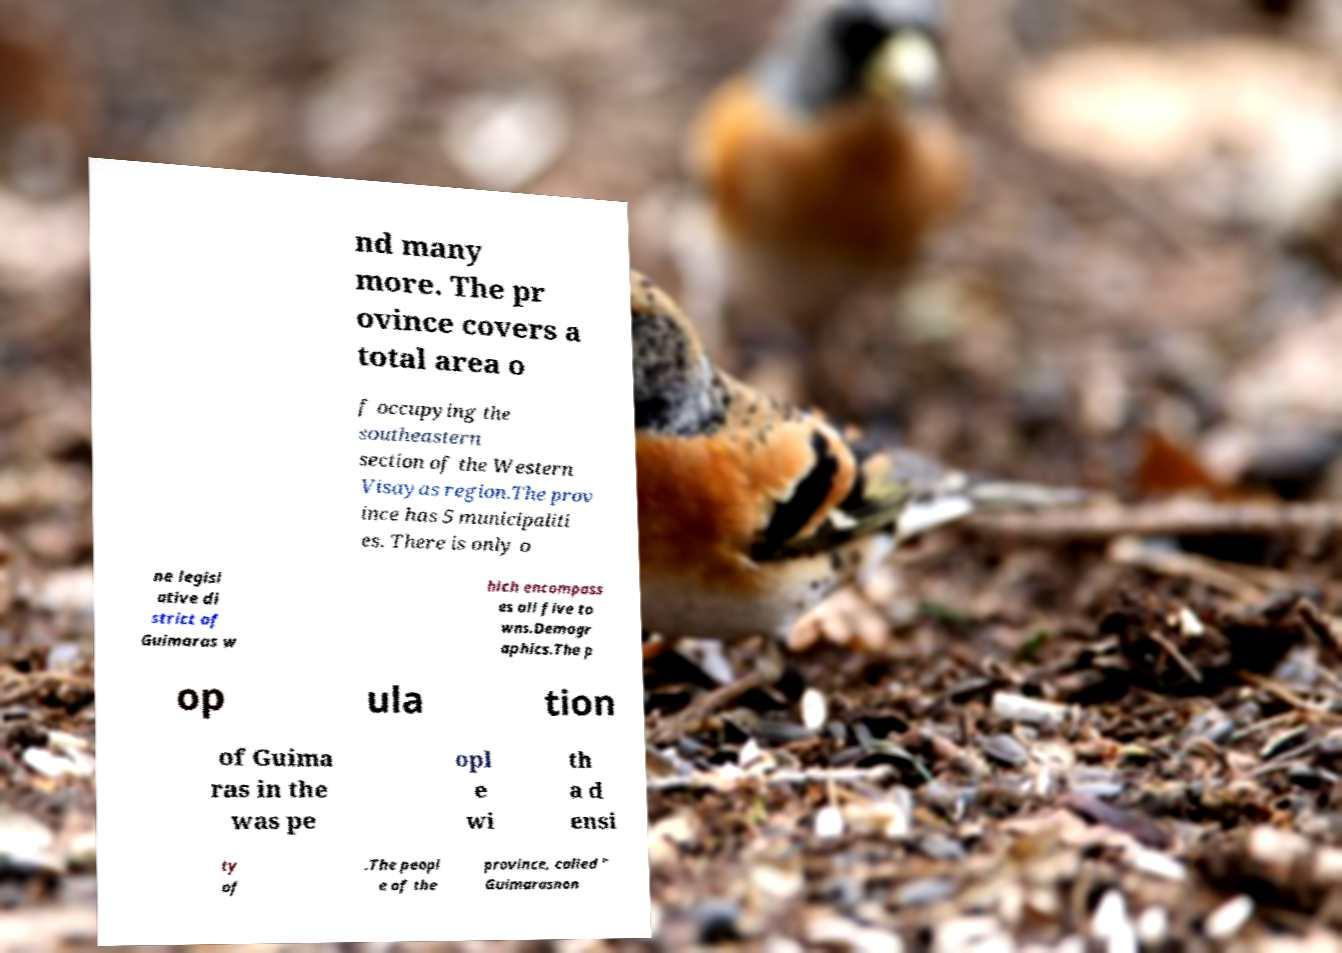Can you accurately transcribe the text from the provided image for me? nd many more. The pr ovince covers a total area o f occupying the southeastern section of the Western Visayas region.The prov ince has 5 municipaliti es. There is only o ne legisl ative di strict of Guimaras w hich encompass es all five to wns.Demogr aphics.The p op ula tion of Guima ras in the was pe opl e wi th a d ensi ty of .The peopl e of the province, called " Guimarasnon 